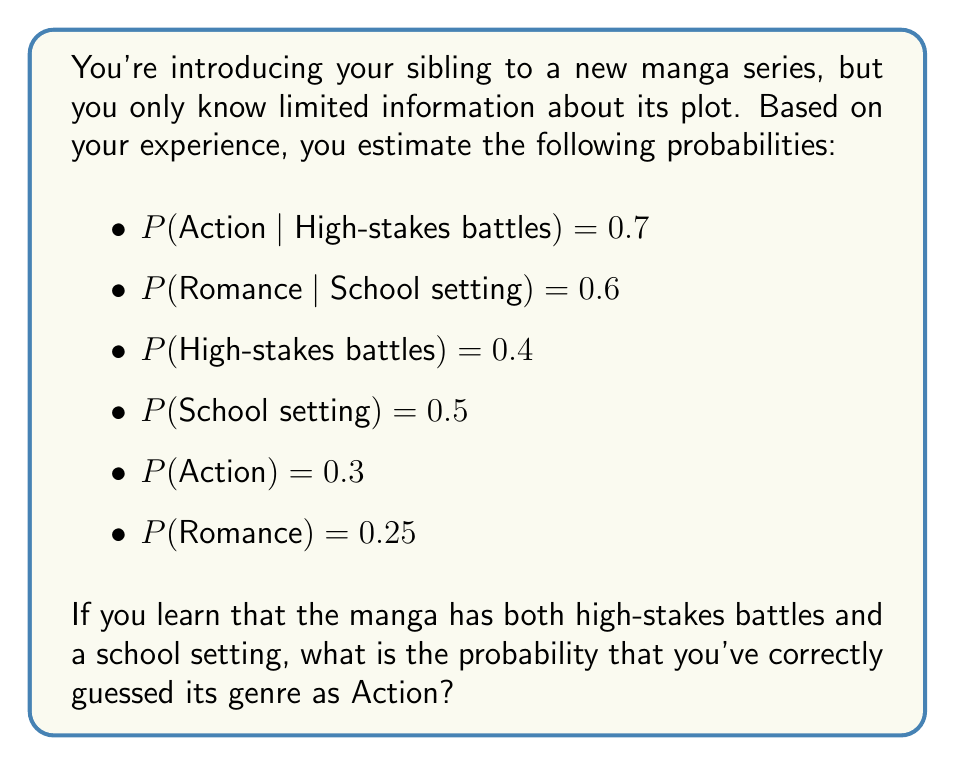Provide a solution to this math problem. To solve this problem, we'll use Bayes' theorem and the given probabilities. Let's break it down step by step:

1) We need to calculate P(Action | High-stakes battles AND School setting).

2) Using Bayes' theorem:

   $$P(A|B,C) = \frac{P(B,C|A) \cdot P(A)}{P(B,C)}$$

   Where A is Action, B is High-stakes battles, and C is School setting.

3) We need to calculate P(B,C|A) and P(B,C):

   P(B,C|A) = P(B|A) * P(C|A) (assuming independence)
   P(B|A) = P(A|B) * P(B) / P(A) = 0.7 * 0.4 / 0.3 = 0.933
   P(C|A) is not given, so we'll use P(C) as an estimate: 0.5

   Therefore, P(B,C|A) ≈ 0.933 * 0.5 = 0.4665

4) P(B,C) = P(B) * P(C) (assuming independence) = 0.4 * 0.5 = 0.2

5) Now we can apply Bayes' theorem:

   $$P(A|B,C) = \frac{0.4665 \cdot 0.3}{0.2} = 0.6998$$

Therefore, the probability of correctly guessing the genre as Action, given that the manga has both high-stakes battles and a school setting, is approximately 0.6998 or 69.98%.
Answer: The probability of correctly guessing the manga's genre as Action, given the information about high-stakes battles and school setting, is approximately 0.6998 or 69.98%. 